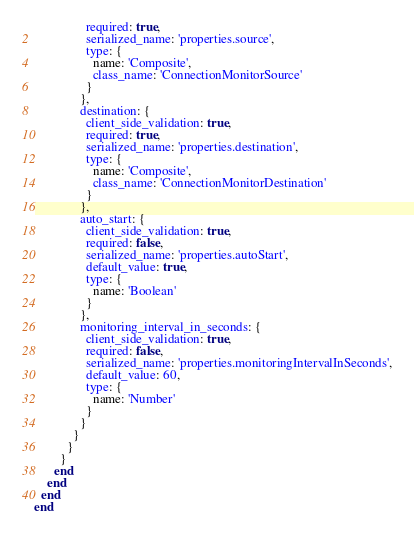Convert code to text. <code><loc_0><loc_0><loc_500><loc_500><_Ruby_>                required: true,
                serialized_name: 'properties.source',
                type: {
                  name: 'Composite',
                  class_name: 'ConnectionMonitorSource'
                }
              },
              destination: {
                client_side_validation: true,
                required: true,
                serialized_name: 'properties.destination',
                type: {
                  name: 'Composite',
                  class_name: 'ConnectionMonitorDestination'
                }
              },
              auto_start: {
                client_side_validation: true,
                required: false,
                serialized_name: 'properties.autoStart',
                default_value: true,
                type: {
                  name: 'Boolean'
                }
              },
              monitoring_interval_in_seconds: {
                client_side_validation: true,
                required: false,
                serialized_name: 'properties.monitoringIntervalInSeconds',
                default_value: 60,
                type: {
                  name: 'Number'
                }
              }
            }
          }
        }
      end
    end
  end
end
</code> 